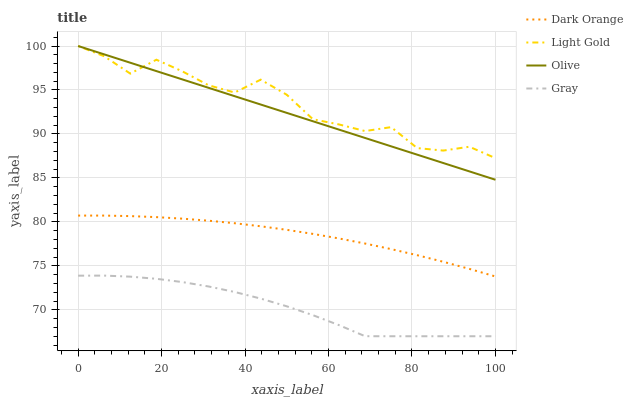Does Gray have the minimum area under the curve?
Answer yes or no. Yes. Does Light Gold have the maximum area under the curve?
Answer yes or no. Yes. Does Dark Orange have the minimum area under the curve?
Answer yes or no. No. Does Dark Orange have the maximum area under the curve?
Answer yes or no. No. Is Olive the smoothest?
Answer yes or no. Yes. Is Light Gold the roughest?
Answer yes or no. Yes. Is Dark Orange the smoothest?
Answer yes or no. No. Is Dark Orange the roughest?
Answer yes or no. No. Does Gray have the lowest value?
Answer yes or no. Yes. Does Dark Orange have the lowest value?
Answer yes or no. No. Does Light Gold have the highest value?
Answer yes or no. Yes. Does Dark Orange have the highest value?
Answer yes or no. No. Is Gray less than Olive?
Answer yes or no. Yes. Is Dark Orange greater than Gray?
Answer yes or no. Yes. Does Light Gold intersect Olive?
Answer yes or no. Yes. Is Light Gold less than Olive?
Answer yes or no. No. Is Light Gold greater than Olive?
Answer yes or no. No. Does Gray intersect Olive?
Answer yes or no. No. 